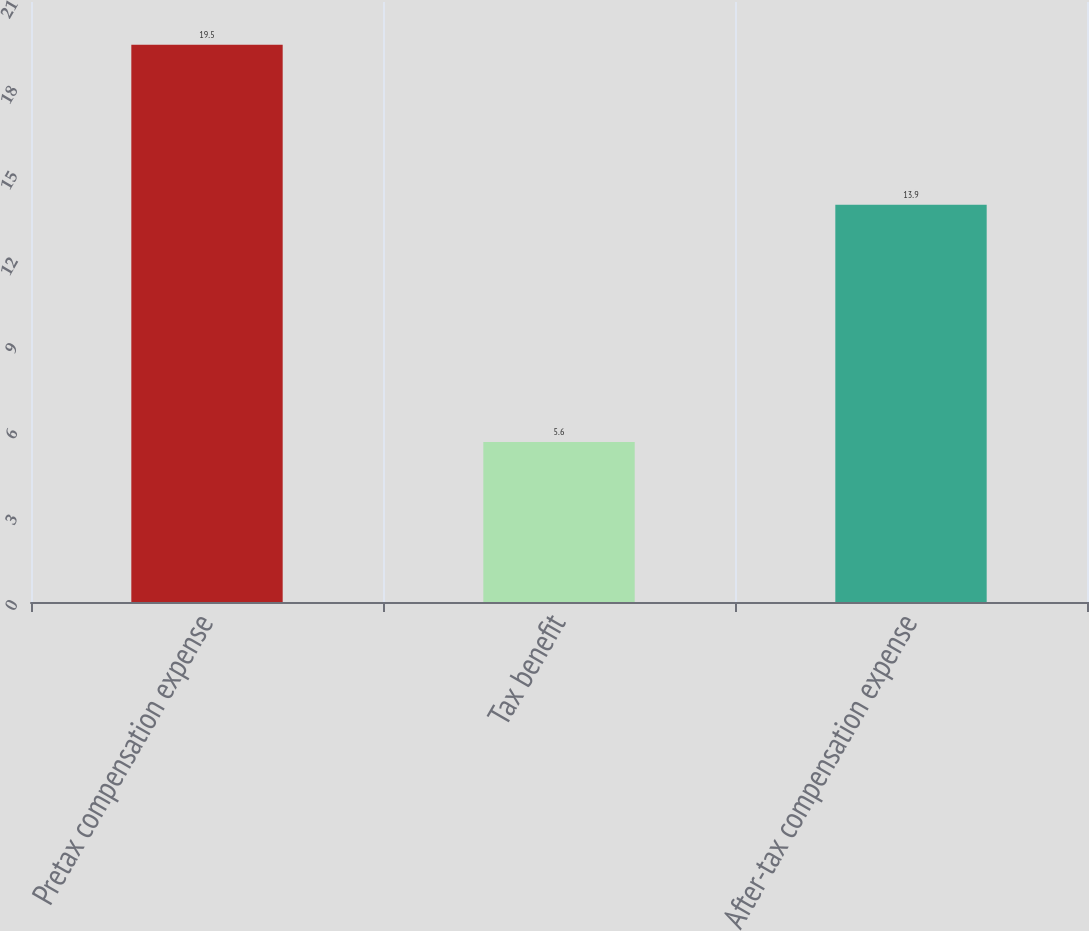<chart> <loc_0><loc_0><loc_500><loc_500><bar_chart><fcel>Pretax compensation expense<fcel>Tax benefit<fcel>After-tax compensation expense<nl><fcel>19.5<fcel>5.6<fcel>13.9<nl></chart> 